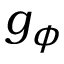<formula> <loc_0><loc_0><loc_500><loc_500>g _ { \phi }</formula> 